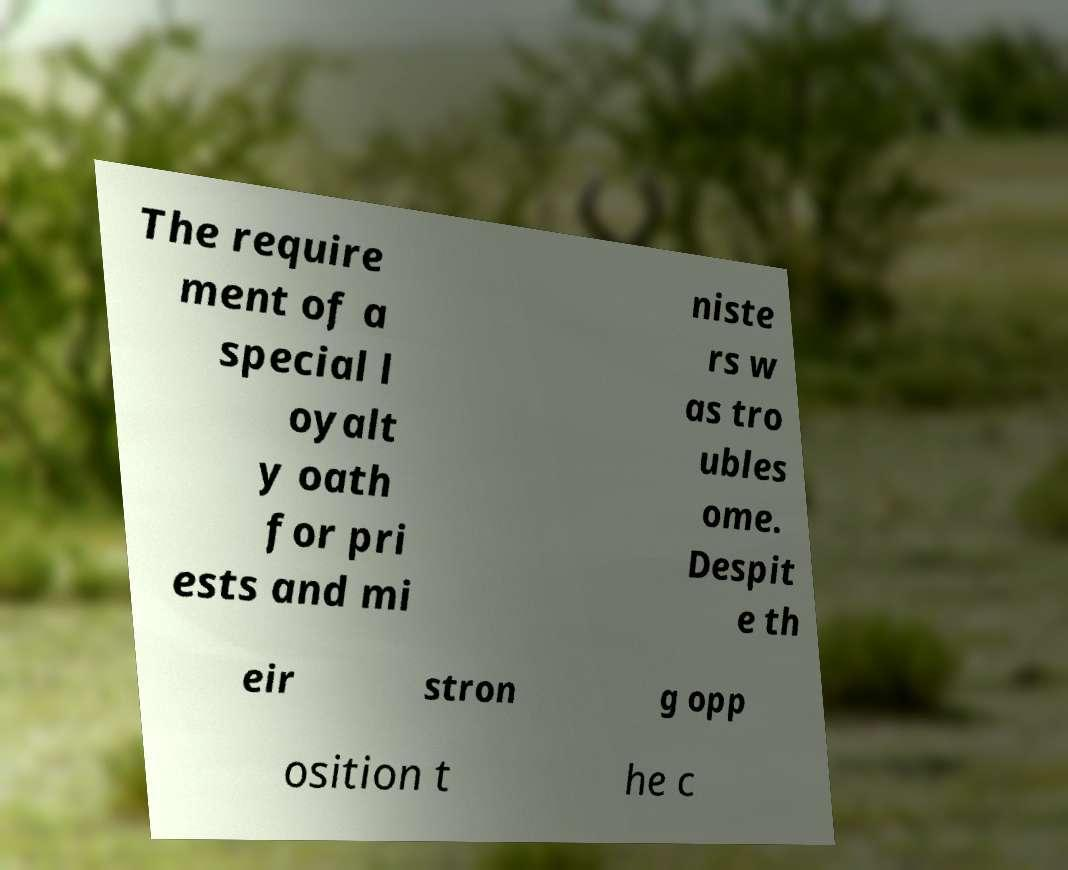I need the written content from this picture converted into text. Can you do that? The require ment of a special l oyalt y oath for pri ests and mi niste rs w as tro ubles ome. Despit e th eir stron g opp osition t he c 